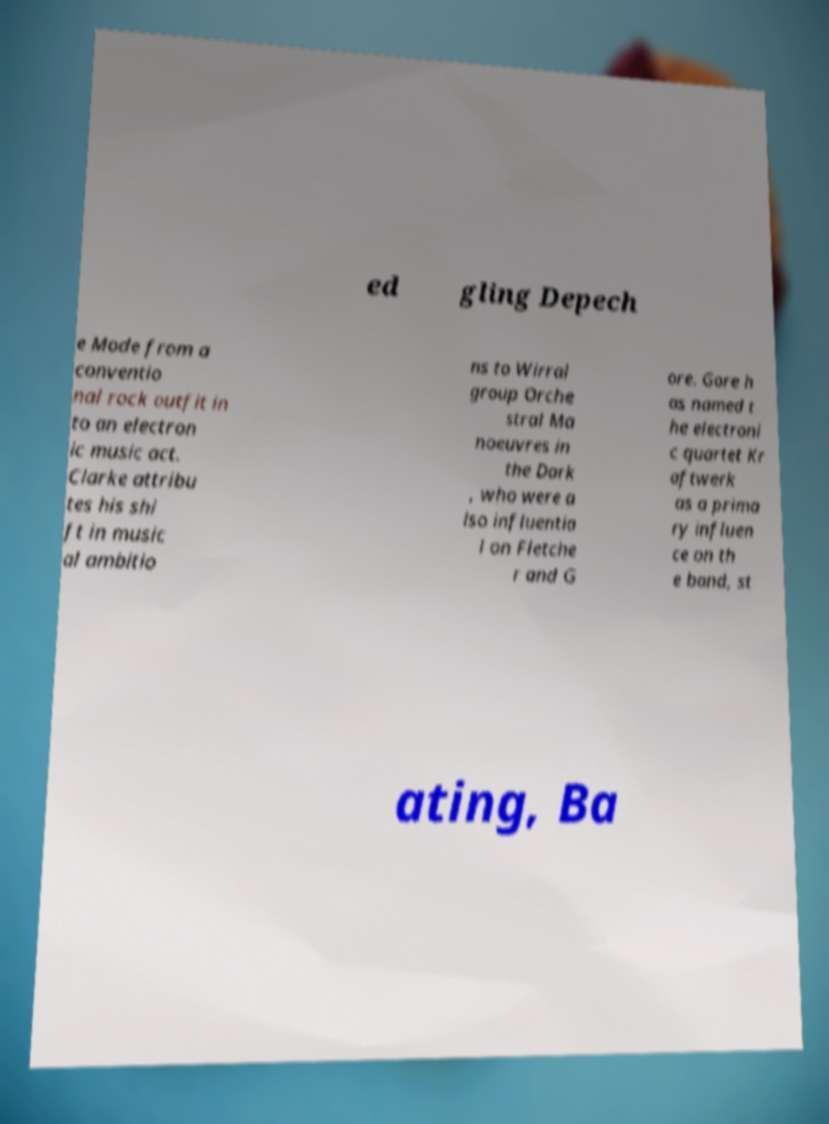Can you read and provide the text displayed in the image?This photo seems to have some interesting text. Can you extract and type it out for me? ed gling Depech e Mode from a conventio nal rock outfit in to an electron ic music act. Clarke attribu tes his shi ft in music al ambitio ns to Wirral group Orche stral Ma noeuvres in the Dark , who were a lso influentia l on Fletche r and G ore. Gore h as named t he electroni c quartet Kr aftwerk as a prima ry influen ce on th e band, st ating, Ba 